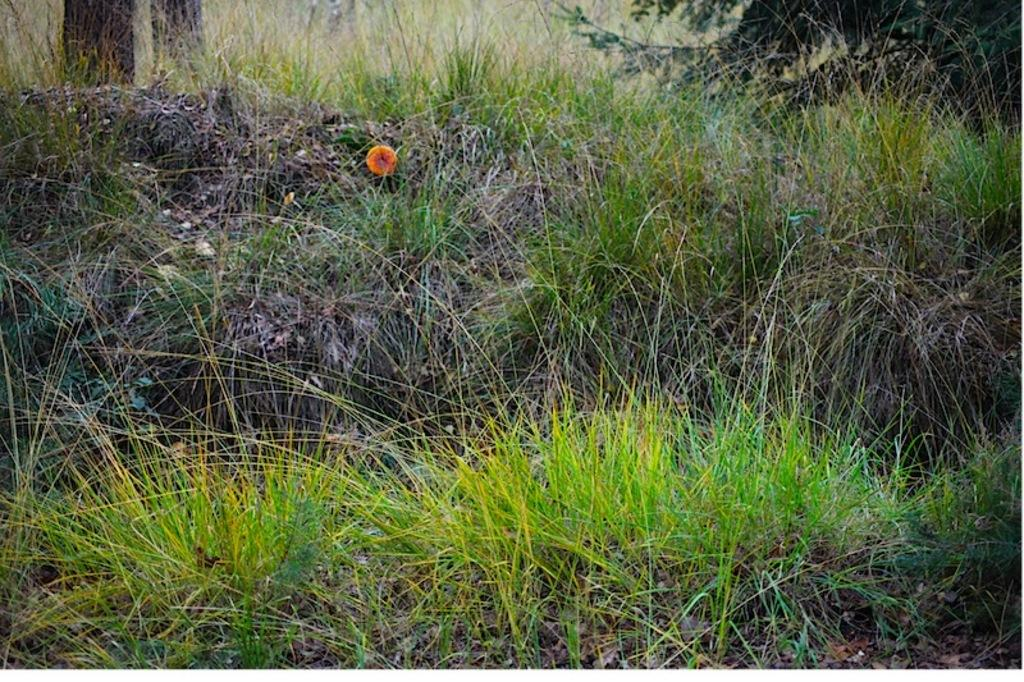What type of vegetation can be seen in the image? There is grass in the image. Where are the tree trunks located in the image? The tree trunks are at the top left side of the image. Can you identify any other plant life in the image? There is a possible flower in the image. How does the plant stretch its leaves in the image? There is no plant with leaves visible in the image, as it only shows grass and tree trunks. 